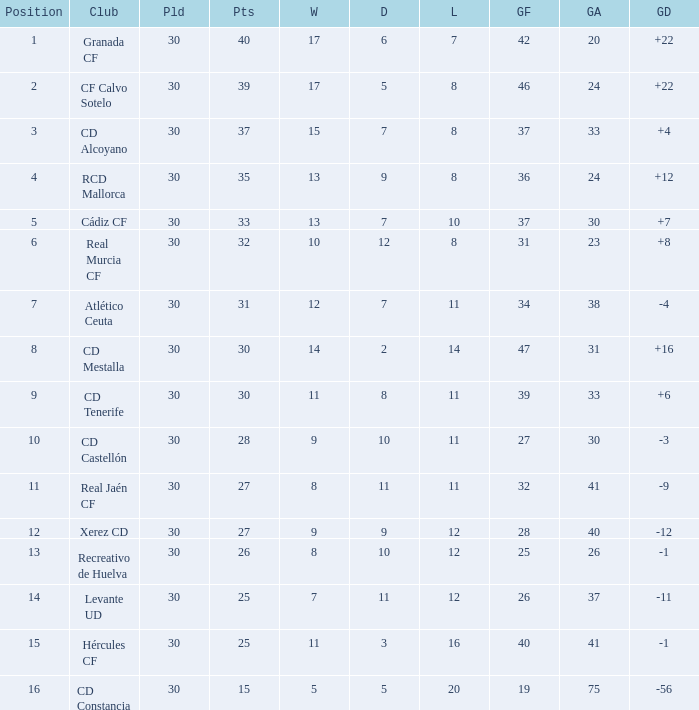Which Played has a Club of atlético ceuta, and less than 11 Losses? None. 